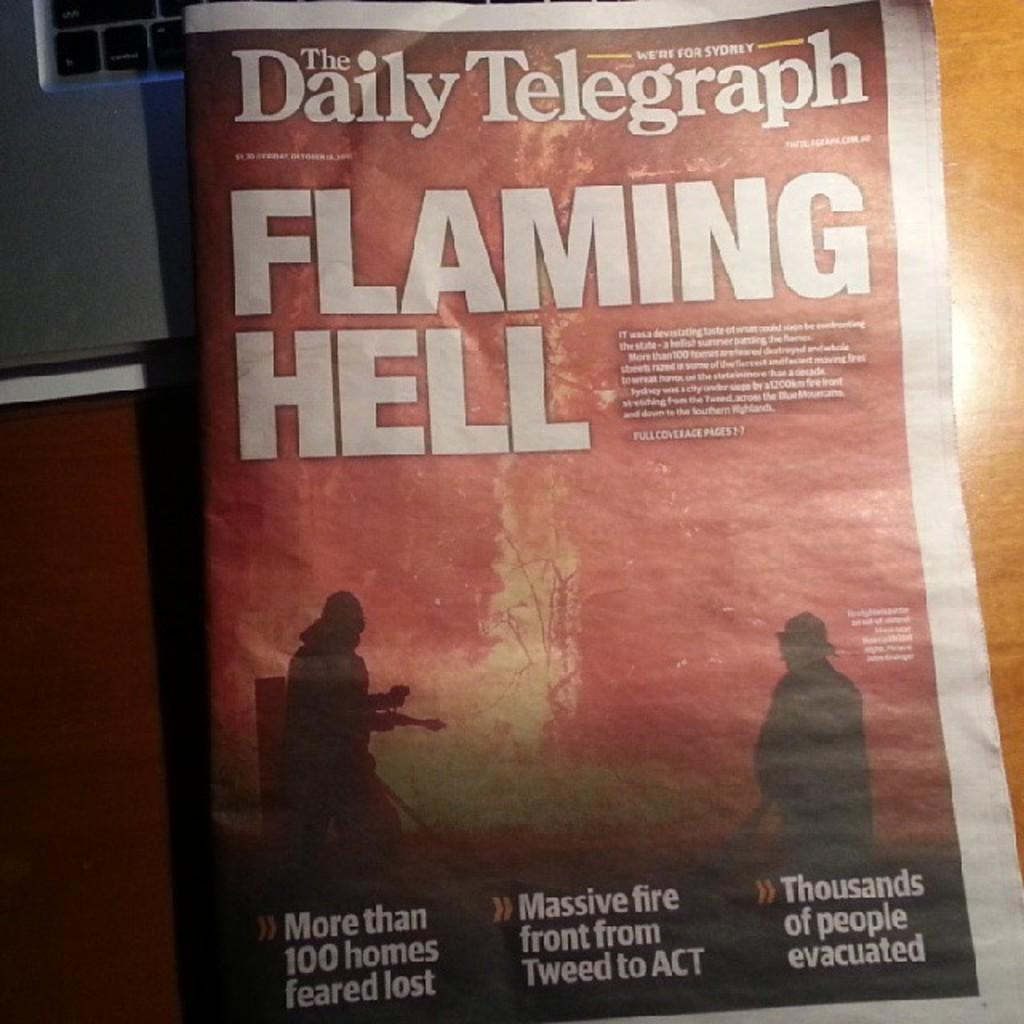<image>
Create a compact narrative representing the image presented. A paper that says the Daily Telegraph and Flaming Hell on the cover. 